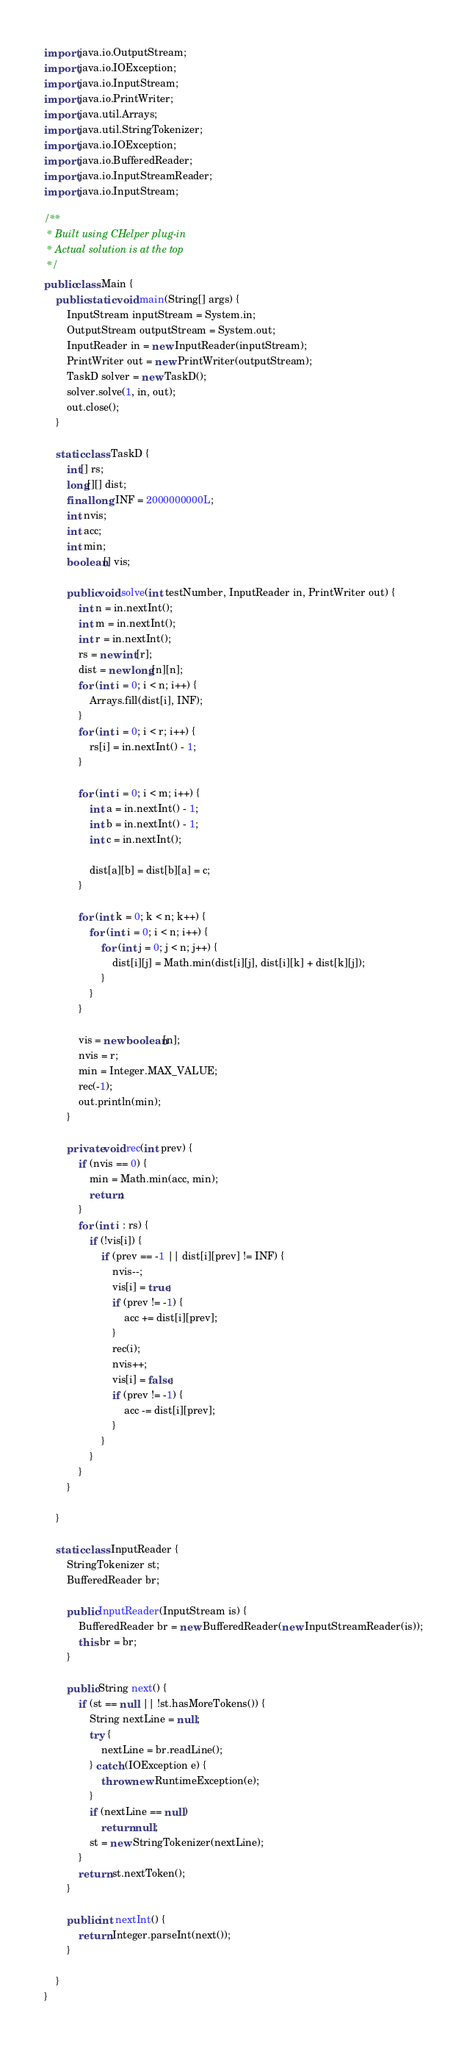<code> <loc_0><loc_0><loc_500><loc_500><_Java_>import java.io.OutputStream;
import java.io.IOException;
import java.io.InputStream;
import java.io.PrintWriter;
import java.util.Arrays;
import java.util.StringTokenizer;
import java.io.IOException;
import java.io.BufferedReader;
import java.io.InputStreamReader;
import java.io.InputStream;

/**
 * Built using CHelper plug-in
 * Actual solution is at the top
 */
public class Main {
    public static void main(String[] args) {
        InputStream inputStream = System.in;
        OutputStream outputStream = System.out;
        InputReader in = new InputReader(inputStream);
        PrintWriter out = new PrintWriter(outputStream);
        TaskD solver = new TaskD();
        solver.solve(1, in, out);
        out.close();
    }

    static class TaskD {
        int[] rs;
        long[][] dist;
        final long INF = 2000000000L;
        int nvis;
        int acc;
        int min;
        boolean[] vis;

        public void solve(int testNumber, InputReader in, PrintWriter out) {
            int n = in.nextInt();
            int m = in.nextInt();
            int r = in.nextInt();
            rs = new int[r];
            dist = new long[n][n];
            for (int i = 0; i < n; i++) {
                Arrays.fill(dist[i], INF);
            }
            for (int i = 0; i < r; i++) {
                rs[i] = in.nextInt() - 1;
            }

            for (int i = 0; i < m; i++) {
                int a = in.nextInt() - 1;
                int b = in.nextInt() - 1;
                int c = in.nextInt();

                dist[a][b] = dist[b][a] = c;
            }

            for (int k = 0; k < n; k++) {
                for (int i = 0; i < n; i++) {
                    for (int j = 0; j < n; j++) {
                        dist[i][j] = Math.min(dist[i][j], dist[i][k] + dist[k][j]);
                    }
                }
            }

            vis = new boolean[n];
            nvis = r;
            min = Integer.MAX_VALUE;
            rec(-1);
            out.println(min);
        }

        private void rec(int prev) {
            if (nvis == 0) {
                min = Math.min(acc, min);
                return;
            }
            for (int i : rs) {
                if (!vis[i]) {
                    if (prev == -1 || dist[i][prev] != INF) {
                        nvis--;
                        vis[i] = true;
                        if (prev != -1) {
                            acc += dist[i][prev];
                        }
                        rec(i);
                        nvis++;
                        vis[i] = false;
                        if (prev != -1) {
                            acc -= dist[i][prev];
                        }
                    }
                }
            }
        }

    }

    static class InputReader {
        StringTokenizer st;
        BufferedReader br;

        public InputReader(InputStream is) {
            BufferedReader br = new BufferedReader(new InputStreamReader(is));
            this.br = br;
        }

        public String next() {
            if (st == null || !st.hasMoreTokens()) {
                String nextLine = null;
                try {
                    nextLine = br.readLine();
                } catch (IOException e) {
                    throw new RuntimeException(e);
                }
                if (nextLine == null)
                    return null;
                st = new StringTokenizer(nextLine);
            }
            return st.nextToken();
        }

        public int nextInt() {
            return Integer.parseInt(next());
        }

    }
}

</code> 